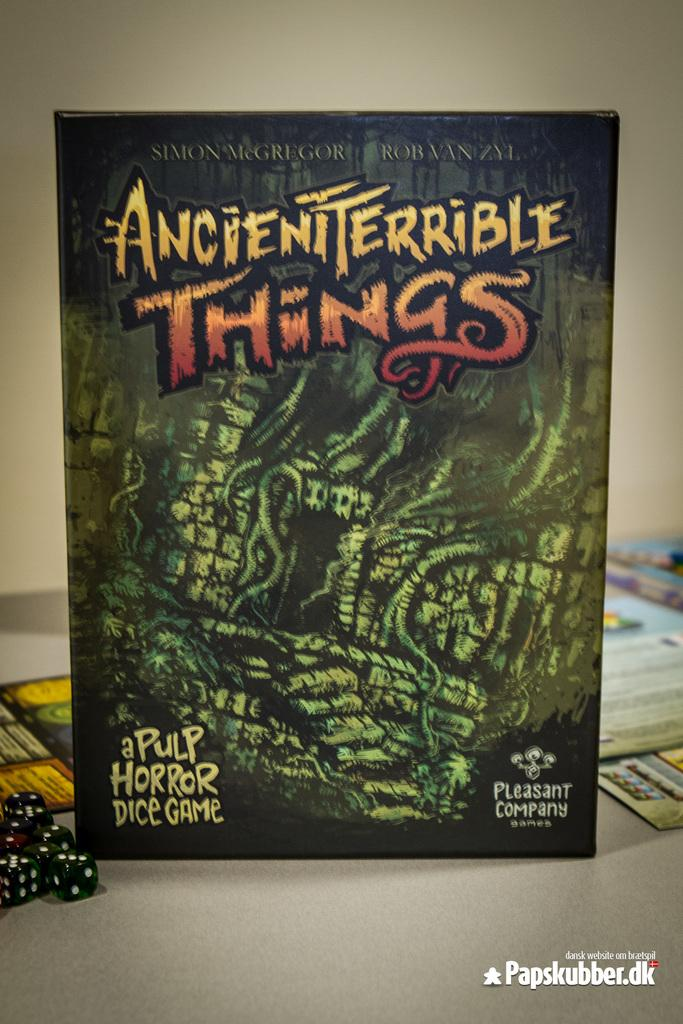Provide a one-sentence caption for the provided image. A close up of a game box which tells us it is a horror game called Ancient Terrible Things. 